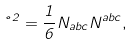Convert formula to latex. <formula><loc_0><loc_0><loc_500><loc_500>\nu ^ { 2 } = \frac { 1 } { 6 } N _ { a b c } N ^ { a b c } ,</formula> 